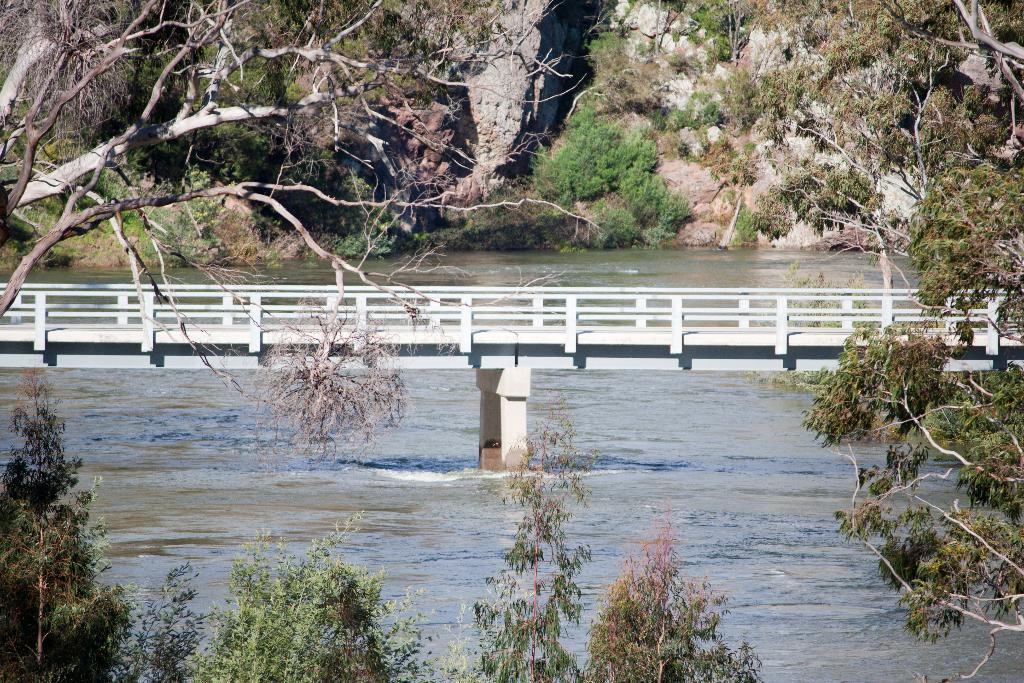What type of natural feature can be seen in the image? There is a river in the image. What structure is present over the river? There is a white bridge in the image. What is the bridge situated on? The bridge is surrounded by rocks. What type of vegetation can be seen in the image? Trees and bushes are visible in the image. What type of receipt can be seen hanging from the trees in the image? There is no receipt present in the image; trees and bushes are the only vegetation mentioned. 